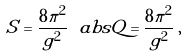<formula> <loc_0><loc_0><loc_500><loc_500>S = \frac { 8 \pi ^ { 2 } } { g ^ { 2 } } \ a b s { Q } = \frac { 8 \pi ^ { 2 } } { g ^ { 2 } } \, ,</formula> 